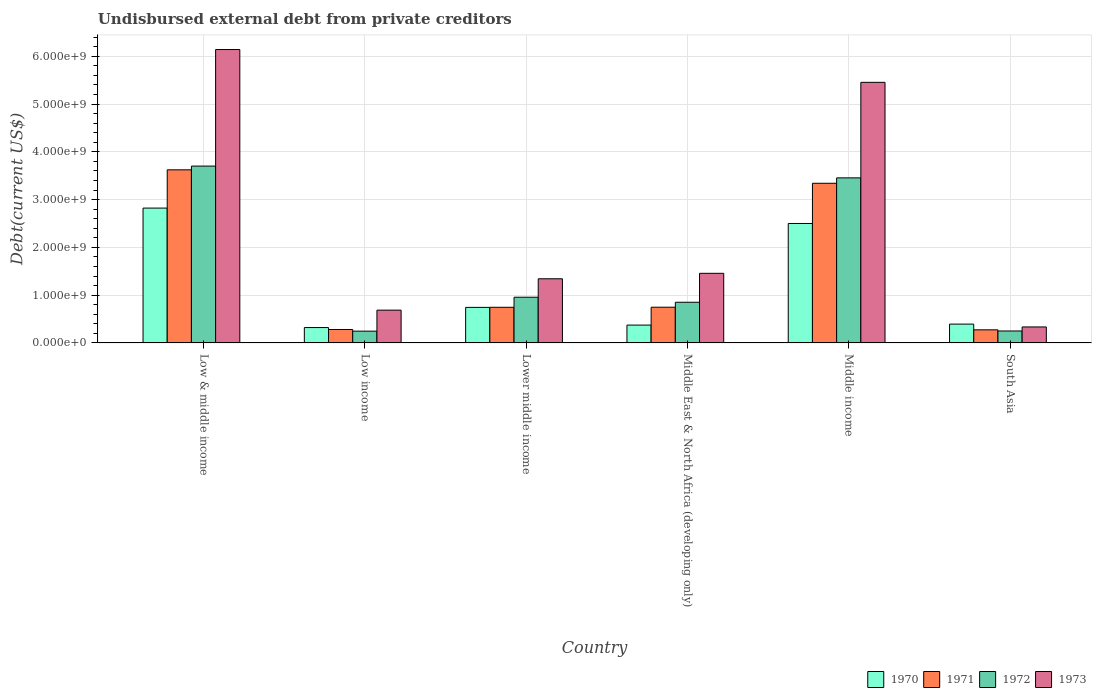How many different coloured bars are there?
Your response must be concise. 4. How many groups of bars are there?
Offer a very short reply. 6. Are the number of bars on each tick of the X-axis equal?
Make the answer very short. Yes. How many bars are there on the 2nd tick from the left?
Offer a very short reply. 4. In how many cases, is the number of bars for a given country not equal to the number of legend labels?
Offer a terse response. 0. What is the total debt in 1972 in Middle East & North Africa (developing only)?
Ensure brevity in your answer.  8.51e+08. Across all countries, what is the maximum total debt in 1971?
Offer a terse response. 3.62e+09. Across all countries, what is the minimum total debt in 1973?
Your response must be concise. 3.35e+08. In which country was the total debt in 1970 minimum?
Offer a very short reply. Low income. What is the total total debt in 1971 in the graph?
Your response must be concise. 9.01e+09. What is the difference between the total debt in 1973 in Low & middle income and that in Middle income?
Offer a terse response. 6.86e+08. What is the difference between the total debt in 1970 in Low income and the total debt in 1973 in Lower middle income?
Provide a succinct answer. -1.02e+09. What is the average total debt in 1971 per country?
Provide a succinct answer. 1.50e+09. What is the difference between the total debt of/in 1970 and total debt of/in 1971 in South Asia?
Offer a terse response. 1.20e+08. In how many countries, is the total debt in 1973 greater than 200000000 US$?
Keep it short and to the point. 6. What is the ratio of the total debt in 1970 in Low income to that in Lower middle income?
Give a very brief answer. 0.43. What is the difference between the highest and the second highest total debt in 1970?
Keep it short and to the point. 2.08e+09. What is the difference between the highest and the lowest total debt in 1973?
Provide a succinct answer. 5.81e+09. Is it the case that in every country, the sum of the total debt in 1973 and total debt in 1972 is greater than the sum of total debt in 1971 and total debt in 1970?
Provide a short and direct response. No. What does the 3rd bar from the left in South Asia represents?
Offer a very short reply. 1972. Are all the bars in the graph horizontal?
Make the answer very short. No. How many countries are there in the graph?
Keep it short and to the point. 6. Are the values on the major ticks of Y-axis written in scientific E-notation?
Your answer should be very brief. Yes. Does the graph contain grids?
Offer a very short reply. Yes. How many legend labels are there?
Ensure brevity in your answer.  4. How are the legend labels stacked?
Offer a terse response. Horizontal. What is the title of the graph?
Keep it short and to the point. Undisbursed external debt from private creditors. What is the label or title of the X-axis?
Make the answer very short. Country. What is the label or title of the Y-axis?
Give a very brief answer. Debt(current US$). What is the Debt(current US$) in 1970 in Low & middle income?
Ensure brevity in your answer.  2.82e+09. What is the Debt(current US$) in 1971 in Low & middle income?
Give a very brief answer. 3.62e+09. What is the Debt(current US$) of 1972 in Low & middle income?
Keep it short and to the point. 3.70e+09. What is the Debt(current US$) in 1973 in Low & middle income?
Provide a succinct answer. 6.14e+09. What is the Debt(current US$) in 1970 in Low income?
Make the answer very short. 3.22e+08. What is the Debt(current US$) of 1971 in Low income?
Ensure brevity in your answer.  2.82e+08. What is the Debt(current US$) in 1972 in Low income?
Your answer should be very brief. 2.47e+08. What is the Debt(current US$) of 1973 in Low income?
Offer a terse response. 6.86e+08. What is the Debt(current US$) of 1970 in Lower middle income?
Ensure brevity in your answer.  7.44e+08. What is the Debt(current US$) in 1971 in Lower middle income?
Your response must be concise. 7.46e+08. What is the Debt(current US$) of 1972 in Lower middle income?
Your answer should be compact. 9.57e+08. What is the Debt(current US$) of 1973 in Lower middle income?
Offer a terse response. 1.34e+09. What is the Debt(current US$) in 1970 in Middle East & North Africa (developing only)?
Provide a short and direct response. 3.74e+08. What is the Debt(current US$) of 1971 in Middle East & North Africa (developing only)?
Offer a very short reply. 7.48e+08. What is the Debt(current US$) in 1972 in Middle East & North Africa (developing only)?
Make the answer very short. 8.51e+08. What is the Debt(current US$) of 1973 in Middle East & North Africa (developing only)?
Make the answer very short. 1.46e+09. What is the Debt(current US$) in 1970 in Middle income?
Make the answer very short. 2.50e+09. What is the Debt(current US$) of 1971 in Middle income?
Make the answer very short. 3.34e+09. What is the Debt(current US$) of 1972 in Middle income?
Your response must be concise. 3.45e+09. What is the Debt(current US$) of 1973 in Middle income?
Provide a short and direct response. 5.45e+09. What is the Debt(current US$) of 1970 in South Asia?
Your answer should be very brief. 3.94e+08. What is the Debt(current US$) of 1971 in South Asia?
Provide a short and direct response. 2.74e+08. What is the Debt(current US$) of 1972 in South Asia?
Your answer should be compact. 2.50e+08. What is the Debt(current US$) in 1973 in South Asia?
Your answer should be very brief. 3.35e+08. Across all countries, what is the maximum Debt(current US$) of 1970?
Offer a terse response. 2.82e+09. Across all countries, what is the maximum Debt(current US$) in 1971?
Offer a terse response. 3.62e+09. Across all countries, what is the maximum Debt(current US$) of 1972?
Your answer should be very brief. 3.70e+09. Across all countries, what is the maximum Debt(current US$) in 1973?
Offer a very short reply. 6.14e+09. Across all countries, what is the minimum Debt(current US$) in 1970?
Keep it short and to the point. 3.22e+08. Across all countries, what is the minimum Debt(current US$) in 1971?
Offer a very short reply. 2.74e+08. Across all countries, what is the minimum Debt(current US$) in 1972?
Your response must be concise. 2.47e+08. Across all countries, what is the minimum Debt(current US$) of 1973?
Your answer should be very brief. 3.35e+08. What is the total Debt(current US$) in 1970 in the graph?
Ensure brevity in your answer.  7.16e+09. What is the total Debt(current US$) of 1971 in the graph?
Your answer should be compact. 9.01e+09. What is the total Debt(current US$) in 1972 in the graph?
Keep it short and to the point. 9.46e+09. What is the total Debt(current US$) of 1973 in the graph?
Ensure brevity in your answer.  1.54e+1. What is the difference between the Debt(current US$) in 1970 in Low & middle income and that in Low income?
Offer a terse response. 2.50e+09. What is the difference between the Debt(current US$) of 1971 in Low & middle income and that in Low income?
Give a very brief answer. 3.34e+09. What is the difference between the Debt(current US$) in 1972 in Low & middle income and that in Low income?
Offer a very short reply. 3.45e+09. What is the difference between the Debt(current US$) in 1973 in Low & middle income and that in Low income?
Offer a terse response. 5.45e+09. What is the difference between the Debt(current US$) in 1970 in Low & middle income and that in Lower middle income?
Provide a succinct answer. 2.08e+09. What is the difference between the Debt(current US$) in 1971 in Low & middle income and that in Lower middle income?
Provide a succinct answer. 2.88e+09. What is the difference between the Debt(current US$) in 1972 in Low & middle income and that in Lower middle income?
Ensure brevity in your answer.  2.74e+09. What is the difference between the Debt(current US$) of 1973 in Low & middle income and that in Lower middle income?
Your response must be concise. 4.80e+09. What is the difference between the Debt(current US$) of 1970 in Low & middle income and that in Middle East & North Africa (developing only)?
Your answer should be very brief. 2.45e+09. What is the difference between the Debt(current US$) in 1971 in Low & middle income and that in Middle East & North Africa (developing only)?
Your response must be concise. 2.88e+09. What is the difference between the Debt(current US$) of 1972 in Low & middle income and that in Middle East & North Africa (developing only)?
Offer a terse response. 2.85e+09. What is the difference between the Debt(current US$) in 1973 in Low & middle income and that in Middle East & North Africa (developing only)?
Your response must be concise. 4.68e+09. What is the difference between the Debt(current US$) in 1970 in Low & middle income and that in Middle income?
Keep it short and to the point. 3.22e+08. What is the difference between the Debt(current US$) of 1971 in Low & middle income and that in Middle income?
Make the answer very short. 2.82e+08. What is the difference between the Debt(current US$) in 1972 in Low & middle income and that in Middle income?
Keep it short and to the point. 2.47e+08. What is the difference between the Debt(current US$) in 1973 in Low & middle income and that in Middle income?
Ensure brevity in your answer.  6.86e+08. What is the difference between the Debt(current US$) of 1970 in Low & middle income and that in South Asia?
Offer a terse response. 2.43e+09. What is the difference between the Debt(current US$) in 1971 in Low & middle income and that in South Asia?
Provide a short and direct response. 3.35e+09. What is the difference between the Debt(current US$) of 1972 in Low & middle income and that in South Asia?
Your response must be concise. 3.45e+09. What is the difference between the Debt(current US$) of 1973 in Low & middle income and that in South Asia?
Offer a terse response. 5.81e+09. What is the difference between the Debt(current US$) of 1970 in Low income and that in Lower middle income?
Keep it short and to the point. -4.22e+08. What is the difference between the Debt(current US$) in 1971 in Low income and that in Lower middle income?
Give a very brief answer. -4.65e+08. What is the difference between the Debt(current US$) of 1972 in Low income and that in Lower middle income?
Give a very brief answer. -7.10e+08. What is the difference between the Debt(current US$) in 1973 in Low income and that in Lower middle income?
Your answer should be very brief. -6.56e+08. What is the difference between the Debt(current US$) of 1970 in Low income and that in Middle East & North Africa (developing only)?
Make the answer very short. -5.15e+07. What is the difference between the Debt(current US$) of 1971 in Low income and that in Middle East & North Africa (developing only)?
Give a very brief answer. -4.66e+08. What is the difference between the Debt(current US$) in 1972 in Low income and that in Middle East & North Africa (developing only)?
Ensure brevity in your answer.  -6.05e+08. What is the difference between the Debt(current US$) in 1973 in Low income and that in Middle East & North Africa (developing only)?
Your answer should be compact. -7.71e+08. What is the difference between the Debt(current US$) of 1970 in Low income and that in Middle income?
Provide a short and direct response. -2.18e+09. What is the difference between the Debt(current US$) of 1971 in Low income and that in Middle income?
Offer a very short reply. -3.06e+09. What is the difference between the Debt(current US$) of 1972 in Low income and that in Middle income?
Ensure brevity in your answer.  -3.21e+09. What is the difference between the Debt(current US$) of 1973 in Low income and that in Middle income?
Offer a very short reply. -4.77e+09. What is the difference between the Debt(current US$) of 1970 in Low income and that in South Asia?
Offer a terse response. -7.22e+07. What is the difference between the Debt(current US$) of 1971 in Low income and that in South Asia?
Your answer should be compact. 7.14e+06. What is the difference between the Debt(current US$) in 1972 in Low income and that in South Asia?
Keep it short and to the point. -3.44e+06. What is the difference between the Debt(current US$) in 1973 in Low income and that in South Asia?
Your response must be concise. 3.52e+08. What is the difference between the Debt(current US$) of 1970 in Lower middle income and that in Middle East & North Africa (developing only)?
Ensure brevity in your answer.  3.71e+08. What is the difference between the Debt(current US$) of 1971 in Lower middle income and that in Middle East & North Africa (developing only)?
Your answer should be compact. -1.62e+06. What is the difference between the Debt(current US$) of 1972 in Lower middle income and that in Middle East & North Africa (developing only)?
Keep it short and to the point. 1.05e+08. What is the difference between the Debt(current US$) of 1973 in Lower middle income and that in Middle East & North Africa (developing only)?
Provide a succinct answer. -1.14e+08. What is the difference between the Debt(current US$) of 1970 in Lower middle income and that in Middle income?
Ensure brevity in your answer.  -1.76e+09. What is the difference between the Debt(current US$) in 1971 in Lower middle income and that in Middle income?
Provide a short and direct response. -2.60e+09. What is the difference between the Debt(current US$) of 1972 in Lower middle income and that in Middle income?
Your answer should be compact. -2.50e+09. What is the difference between the Debt(current US$) of 1973 in Lower middle income and that in Middle income?
Make the answer very short. -4.11e+09. What is the difference between the Debt(current US$) in 1970 in Lower middle income and that in South Asia?
Make the answer very short. 3.50e+08. What is the difference between the Debt(current US$) of 1971 in Lower middle income and that in South Asia?
Provide a short and direct response. 4.72e+08. What is the difference between the Debt(current US$) of 1972 in Lower middle income and that in South Asia?
Your answer should be very brief. 7.07e+08. What is the difference between the Debt(current US$) in 1973 in Lower middle income and that in South Asia?
Provide a short and direct response. 1.01e+09. What is the difference between the Debt(current US$) in 1970 in Middle East & North Africa (developing only) and that in Middle income?
Give a very brief answer. -2.13e+09. What is the difference between the Debt(current US$) in 1971 in Middle East & North Africa (developing only) and that in Middle income?
Your answer should be compact. -2.59e+09. What is the difference between the Debt(current US$) of 1972 in Middle East & North Africa (developing only) and that in Middle income?
Keep it short and to the point. -2.60e+09. What is the difference between the Debt(current US$) of 1973 in Middle East & North Africa (developing only) and that in Middle income?
Provide a short and direct response. -4.00e+09. What is the difference between the Debt(current US$) in 1970 in Middle East & North Africa (developing only) and that in South Asia?
Offer a very short reply. -2.07e+07. What is the difference between the Debt(current US$) in 1971 in Middle East & North Africa (developing only) and that in South Asia?
Provide a short and direct response. 4.74e+08. What is the difference between the Debt(current US$) of 1972 in Middle East & North Africa (developing only) and that in South Asia?
Offer a terse response. 6.01e+08. What is the difference between the Debt(current US$) in 1973 in Middle East & North Africa (developing only) and that in South Asia?
Your answer should be very brief. 1.12e+09. What is the difference between the Debt(current US$) of 1970 in Middle income and that in South Asia?
Give a very brief answer. 2.11e+09. What is the difference between the Debt(current US$) in 1971 in Middle income and that in South Asia?
Provide a short and direct response. 3.07e+09. What is the difference between the Debt(current US$) in 1972 in Middle income and that in South Asia?
Keep it short and to the point. 3.20e+09. What is the difference between the Debt(current US$) of 1973 in Middle income and that in South Asia?
Your response must be concise. 5.12e+09. What is the difference between the Debt(current US$) in 1970 in Low & middle income and the Debt(current US$) in 1971 in Low income?
Provide a succinct answer. 2.54e+09. What is the difference between the Debt(current US$) in 1970 in Low & middle income and the Debt(current US$) in 1972 in Low income?
Make the answer very short. 2.58e+09. What is the difference between the Debt(current US$) of 1970 in Low & middle income and the Debt(current US$) of 1973 in Low income?
Give a very brief answer. 2.14e+09. What is the difference between the Debt(current US$) of 1971 in Low & middle income and the Debt(current US$) of 1972 in Low income?
Your answer should be compact. 3.38e+09. What is the difference between the Debt(current US$) in 1971 in Low & middle income and the Debt(current US$) in 1973 in Low income?
Your answer should be very brief. 2.94e+09. What is the difference between the Debt(current US$) of 1972 in Low & middle income and the Debt(current US$) of 1973 in Low income?
Make the answer very short. 3.02e+09. What is the difference between the Debt(current US$) of 1970 in Low & middle income and the Debt(current US$) of 1971 in Lower middle income?
Offer a very short reply. 2.08e+09. What is the difference between the Debt(current US$) in 1970 in Low & middle income and the Debt(current US$) in 1972 in Lower middle income?
Make the answer very short. 1.87e+09. What is the difference between the Debt(current US$) in 1970 in Low & middle income and the Debt(current US$) in 1973 in Lower middle income?
Provide a short and direct response. 1.48e+09. What is the difference between the Debt(current US$) of 1971 in Low & middle income and the Debt(current US$) of 1972 in Lower middle income?
Keep it short and to the point. 2.67e+09. What is the difference between the Debt(current US$) in 1971 in Low & middle income and the Debt(current US$) in 1973 in Lower middle income?
Provide a short and direct response. 2.28e+09. What is the difference between the Debt(current US$) in 1972 in Low & middle income and the Debt(current US$) in 1973 in Lower middle income?
Offer a terse response. 2.36e+09. What is the difference between the Debt(current US$) of 1970 in Low & middle income and the Debt(current US$) of 1971 in Middle East & North Africa (developing only)?
Provide a succinct answer. 2.07e+09. What is the difference between the Debt(current US$) of 1970 in Low & middle income and the Debt(current US$) of 1972 in Middle East & North Africa (developing only)?
Offer a very short reply. 1.97e+09. What is the difference between the Debt(current US$) in 1970 in Low & middle income and the Debt(current US$) in 1973 in Middle East & North Africa (developing only)?
Keep it short and to the point. 1.37e+09. What is the difference between the Debt(current US$) in 1971 in Low & middle income and the Debt(current US$) in 1972 in Middle East & North Africa (developing only)?
Your answer should be very brief. 2.77e+09. What is the difference between the Debt(current US$) in 1971 in Low & middle income and the Debt(current US$) in 1973 in Middle East & North Africa (developing only)?
Give a very brief answer. 2.17e+09. What is the difference between the Debt(current US$) in 1972 in Low & middle income and the Debt(current US$) in 1973 in Middle East & North Africa (developing only)?
Give a very brief answer. 2.24e+09. What is the difference between the Debt(current US$) in 1970 in Low & middle income and the Debt(current US$) in 1971 in Middle income?
Your answer should be very brief. -5.19e+08. What is the difference between the Debt(current US$) in 1970 in Low & middle income and the Debt(current US$) in 1972 in Middle income?
Your answer should be very brief. -6.32e+08. What is the difference between the Debt(current US$) of 1970 in Low & middle income and the Debt(current US$) of 1973 in Middle income?
Make the answer very short. -2.63e+09. What is the difference between the Debt(current US$) in 1971 in Low & middle income and the Debt(current US$) in 1972 in Middle income?
Your answer should be very brief. 1.68e+08. What is the difference between the Debt(current US$) of 1971 in Low & middle income and the Debt(current US$) of 1973 in Middle income?
Offer a very short reply. -1.83e+09. What is the difference between the Debt(current US$) in 1972 in Low & middle income and the Debt(current US$) in 1973 in Middle income?
Make the answer very short. -1.75e+09. What is the difference between the Debt(current US$) of 1970 in Low & middle income and the Debt(current US$) of 1971 in South Asia?
Offer a very short reply. 2.55e+09. What is the difference between the Debt(current US$) in 1970 in Low & middle income and the Debt(current US$) in 1972 in South Asia?
Provide a succinct answer. 2.57e+09. What is the difference between the Debt(current US$) of 1970 in Low & middle income and the Debt(current US$) of 1973 in South Asia?
Provide a short and direct response. 2.49e+09. What is the difference between the Debt(current US$) in 1971 in Low & middle income and the Debt(current US$) in 1972 in South Asia?
Your response must be concise. 3.37e+09. What is the difference between the Debt(current US$) in 1971 in Low & middle income and the Debt(current US$) in 1973 in South Asia?
Provide a short and direct response. 3.29e+09. What is the difference between the Debt(current US$) in 1972 in Low & middle income and the Debt(current US$) in 1973 in South Asia?
Offer a very short reply. 3.37e+09. What is the difference between the Debt(current US$) of 1970 in Low income and the Debt(current US$) of 1971 in Lower middle income?
Provide a short and direct response. -4.24e+08. What is the difference between the Debt(current US$) in 1970 in Low income and the Debt(current US$) in 1972 in Lower middle income?
Make the answer very short. -6.35e+08. What is the difference between the Debt(current US$) of 1970 in Low income and the Debt(current US$) of 1973 in Lower middle income?
Make the answer very short. -1.02e+09. What is the difference between the Debt(current US$) in 1971 in Low income and the Debt(current US$) in 1972 in Lower middle income?
Provide a short and direct response. -6.75e+08. What is the difference between the Debt(current US$) in 1971 in Low income and the Debt(current US$) in 1973 in Lower middle income?
Provide a succinct answer. -1.06e+09. What is the difference between the Debt(current US$) in 1972 in Low income and the Debt(current US$) in 1973 in Lower middle income?
Keep it short and to the point. -1.10e+09. What is the difference between the Debt(current US$) in 1970 in Low income and the Debt(current US$) in 1971 in Middle East & North Africa (developing only)?
Your answer should be very brief. -4.26e+08. What is the difference between the Debt(current US$) of 1970 in Low income and the Debt(current US$) of 1972 in Middle East & North Africa (developing only)?
Keep it short and to the point. -5.29e+08. What is the difference between the Debt(current US$) in 1970 in Low income and the Debt(current US$) in 1973 in Middle East & North Africa (developing only)?
Your answer should be compact. -1.13e+09. What is the difference between the Debt(current US$) of 1971 in Low income and the Debt(current US$) of 1972 in Middle East & North Africa (developing only)?
Ensure brevity in your answer.  -5.70e+08. What is the difference between the Debt(current US$) in 1971 in Low income and the Debt(current US$) in 1973 in Middle East & North Africa (developing only)?
Your response must be concise. -1.18e+09. What is the difference between the Debt(current US$) of 1972 in Low income and the Debt(current US$) of 1973 in Middle East & North Africa (developing only)?
Offer a very short reply. -1.21e+09. What is the difference between the Debt(current US$) of 1970 in Low income and the Debt(current US$) of 1971 in Middle income?
Ensure brevity in your answer.  -3.02e+09. What is the difference between the Debt(current US$) of 1970 in Low income and the Debt(current US$) of 1972 in Middle income?
Your answer should be compact. -3.13e+09. What is the difference between the Debt(current US$) of 1970 in Low income and the Debt(current US$) of 1973 in Middle income?
Make the answer very short. -5.13e+09. What is the difference between the Debt(current US$) in 1971 in Low income and the Debt(current US$) in 1972 in Middle income?
Give a very brief answer. -3.17e+09. What is the difference between the Debt(current US$) of 1971 in Low income and the Debt(current US$) of 1973 in Middle income?
Your answer should be very brief. -5.17e+09. What is the difference between the Debt(current US$) of 1972 in Low income and the Debt(current US$) of 1973 in Middle income?
Your answer should be very brief. -5.21e+09. What is the difference between the Debt(current US$) of 1970 in Low income and the Debt(current US$) of 1971 in South Asia?
Provide a succinct answer. 4.77e+07. What is the difference between the Debt(current US$) of 1970 in Low income and the Debt(current US$) of 1972 in South Asia?
Your answer should be very brief. 7.18e+07. What is the difference between the Debt(current US$) in 1970 in Low income and the Debt(current US$) in 1973 in South Asia?
Your answer should be compact. -1.27e+07. What is the difference between the Debt(current US$) in 1971 in Low income and the Debt(current US$) in 1972 in South Asia?
Your response must be concise. 3.13e+07. What is the difference between the Debt(current US$) of 1971 in Low income and the Debt(current US$) of 1973 in South Asia?
Make the answer very short. -5.33e+07. What is the difference between the Debt(current US$) in 1972 in Low income and the Debt(current US$) in 1973 in South Asia?
Ensure brevity in your answer.  -8.80e+07. What is the difference between the Debt(current US$) in 1970 in Lower middle income and the Debt(current US$) in 1971 in Middle East & North Africa (developing only)?
Ensure brevity in your answer.  -3.71e+06. What is the difference between the Debt(current US$) of 1970 in Lower middle income and the Debt(current US$) of 1972 in Middle East & North Africa (developing only)?
Provide a succinct answer. -1.07e+08. What is the difference between the Debt(current US$) in 1970 in Lower middle income and the Debt(current US$) in 1973 in Middle East & North Africa (developing only)?
Your response must be concise. -7.13e+08. What is the difference between the Debt(current US$) of 1971 in Lower middle income and the Debt(current US$) of 1972 in Middle East & North Africa (developing only)?
Ensure brevity in your answer.  -1.05e+08. What is the difference between the Debt(current US$) of 1971 in Lower middle income and the Debt(current US$) of 1973 in Middle East & North Africa (developing only)?
Your answer should be very brief. -7.11e+08. What is the difference between the Debt(current US$) of 1972 in Lower middle income and the Debt(current US$) of 1973 in Middle East & North Africa (developing only)?
Make the answer very short. -5.00e+08. What is the difference between the Debt(current US$) in 1970 in Lower middle income and the Debt(current US$) in 1971 in Middle income?
Your response must be concise. -2.60e+09. What is the difference between the Debt(current US$) of 1970 in Lower middle income and the Debt(current US$) of 1972 in Middle income?
Your response must be concise. -2.71e+09. What is the difference between the Debt(current US$) in 1970 in Lower middle income and the Debt(current US$) in 1973 in Middle income?
Offer a very short reply. -4.71e+09. What is the difference between the Debt(current US$) of 1971 in Lower middle income and the Debt(current US$) of 1972 in Middle income?
Provide a short and direct response. -2.71e+09. What is the difference between the Debt(current US$) in 1971 in Lower middle income and the Debt(current US$) in 1973 in Middle income?
Your answer should be compact. -4.71e+09. What is the difference between the Debt(current US$) in 1972 in Lower middle income and the Debt(current US$) in 1973 in Middle income?
Your response must be concise. -4.50e+09. What is the difference between the Debt(current US$) of 1970 in Lower middle income and the Debt(current US$) of 1971 in South Asia?
Your answer should be compact. 4.70e+08. What is the difference between the Debt(current US$) in 1970 in Lower middle income and the Debt(current US$) in 1972 in South Asia?
Ensure brevity in your answer.  4.94e+08. What is the difference between the Debt(current US$) in 1970 in Lower middle income and the Debt(current US$) in 1973 in South Asia?
Your response must be concise. 4.09e+08. What is the difference between the Debt(current US$) of 1971 in Lower middle income and the Debt(current US$) of 1972 in South Asia?
Your answer should be compact. 4.96e+08. What is the difference between the Debt(current US$) in 1971 in Lower middle income and the Debt(current US$) in 1973 in South Asia?
Provide a short and direct response. 4.11e+08. What is the difference between the Debt(current US$) in 1972 in Lower middle income and the Debt(current US$) in 1973 in South Asia?
Your response must be concise. 6.22e+08. What is the difference between the Debt(current US$) in 1970 in Middle East & North Africa (developing only) and the Debt(current US$) in 1971 in Middle income?
Give a very brief answer. -2.97e+09. What is the difference between the Debt(current US$) in 1970 in Middle East & North Africa (developing only) and the Debt(current US$) in 1972 in Middle income?
Your answer should be very brief. -3.08e+09. What is the difference between the Debt(current US$) in 1970 in Middle East & North Africa (developing only) and the Debt(current US$) in 1973 in Middle income?
Offer a terse response. -5.08e+09. What is the difference between the Debt(current US$) of 1971 in Middle East & North Africa (developing only) and the Debt(current US$) of 1972 in Middle income?
Offer a very short reply. -2.71e+09. What is the difference between the Debt(current US$) in 1971 in Middle East & North Africa (developing only) and the Debt(current US$) in 1973 in Middle income?
Offer a very short reply. -4.71e+09. What is the difference between the Debt(current US$) in 1972 in Middle East & North Africa (developing only) and the Debt(current US$) in 1973 in Middle income?
Make the answer very short. -4.60e+09. What is the difference between the Debt(current US$) of 1970 in Middle East & North Africa (developing only) and the Debt(current US$) of 1971 in South Asia?
Give a very brief answer. 9.92e+07. What is the difference between the Debt(current US$) of 1970 in Middle East & North Africa (developing only) and the Debt(current US$) of 1972 in South Asia?
Your answer should be compact. 1.23e+08. What is the difference between the Debt(current US$) in 1970 in Middle East & North Africa (developing only) and the Debt(current US$) in 1973 in South Asia?
Your response must be concise. 3.88e+07. What is the difference between the Debt(current US$) of 1971 in Middle East & North Africa (developing only) and the Debt(current US$) of 1972 in South Asia?
Provide a short and direct response. 4.98e+08. What is the difference between the Debt(current US$) of 1971 in Middle East & North Africa (developing only) and the Debt(current US$) of 1973 in South Asia?
Your answer should be compact. 4.13e+08. What is the difference between the Debt(current US$) in 1972 in Middle East & North Africa (developing only) and the Debt(current US$) in 1973 in South Asia?
Make the answer very short. 5.17e+08. What is the difference between the Debt(current US$) in 1970 in Middle income and the Debt(current US$) in 1971 in South Asia?
Keep it short and to the point. 2.23e+09. What is the difference between the Debt(current US$) of 1970 in Middle income and the Debt(current US$) of 1972 in South Asia?
Give a very brief answer. 2.25e+09. What is the difference between the Debt(current US$) of 1970 in Middle income and the Debt(current US$) of 1973 in South Asia?
Your answer should be very brief. 2.17e+09. What is the difference between the Debt(current US$) of 1971 in Middle income and the Debt(current US$) of 1972 in South Asia?
Provide a succinct answer. 3.09e+09. What is the difference between the Debt(current US$) in 1971 in Middle income and the Debt(current US$) in 1973 in South Asia?
Ensure brevity in your answer.  3.01e+09. What is the difference between the Debt(current US$) in 1972 in Middle income and the Debt(current US$) in 1973 in South Asia?
Your answer should be very brief. 3.12e+09. What is the average Debt(current US$) of 1970 per country?
Give a very brief answer. 1.19e+09. What is the average Debt(current US$) in 1971 per country?
Make the answer very short. 1.50e+09. What is the average Debt(current US$) of 1972 per country?
Your answer should be very brief. 1.58e+09. What is the average Debt(current US$) in 1973 per country?
Offer a terse response. 2.57e+09. What is the difference between the Debt(current US$) in 1970 and Debt(current US$) in 1971 in Low & middle income?
Offer a very short reply. -8.01e+08. What is the difference between the Debt(current US$) of 1970 and Debt(current US$) of 1972 in Low & middle income?
Make the answer very short. -8.79e+08. What is the difference between the Debt(current US$) of 1970 and Debt(current US$) of 1973 in Low & middle income?
Make the answer very short. -3.32e+09. What is the difference between the Debt(current US$) in 1971 and Debt(current US$) in 1972 in Low & middle income?
Provide a short and direct response. -7.84e+07. What is the difference between the Debt(current US$) of 1971 and Debt(current US$) of 1973 in Low & middle income?
Give a very brief answer. -2.52e+09. What is the difference between the Debt(current US$) of 1972 and Debt(current US$) of 1973 in Low & middle income?
Give a very brief answer. -2.44e+09. What is the difference between the Debt(current US$) of 1970 and Debt(current US$) of 1971 in Low income?
Ensure brevity in your answer.  4.06e+07. What is the difference between the Debt(current US$) in 1970 and Debt(current US$) in 1972 in Low income?
Ensure brevity in your answer.  7.53e+07. What is the difference between the Debt(current US$) in 1970 and Debt(current US$) in 1973 in Low income?
Offer a terse response. -3.64e+08. What is the difference between the Debt(current US$) of 1971 and Debt(current US$) of 1972 in Low income?
Give a very brief answer. 3.47e+07. What is the difference between the Debt(current US$) in 1971 and Debt(current US$) in 1973 in Low income?
Your answer should be very brief. -4.05e+08. What is the difference between the Debt(current US$) in 1972 and Debt(current US$) in 1973 in Low income?
Offer a terse response. -4.40e+08. What is the difference between the Debt(current US$) in 1970 and Debt(current US$) in 1971 in Lower middle income?
Provide a succinct answer. -2.10e+06. What is the difference between the Debt(current US$) of 1970 and Debt(current US$) of 1972 in Lower middle income?
Provide a short and direct response. -2.13e+08. What is the difference between the Debt(current US$) in 1970 and Debt(current US$) in 1973 in Lower middle income?
Offer a very short reply. -5.99e+08. What is the difference between the Debt(current US$) in 1971 and Debt(current US$) in 1972 in Lower middle income?
Make the answer very short. -2.11e+08. What is the difference between the Debt(current US$) of 1971 and Debt(current US$) of 1973 in Lower middle income?
Give a very brief answer. -5.97e+08. What is the difference between the Debt(current US$) of 1972 and Debt(current US$) of 1973 in Lower middle income?
Your answer should be compact. -3.86e+08. What is the difference between the Debt(current US$) of 1970 and Debt(current US$) of 1971 in Middle East & North Africa (developing only)?
Your answer should be compact. -3.74e+08. What is the difference between the Debt(current US$) of 1970 and Debt(current US$) of 1972 in Middle East & North Africa (developing only)?
Your answer should be very brief. -4.78e+08. What is the difference between the Debt(current US$) of 1970 and Debt(current US$) of 1973 in Middle East & North Africa (developing only)?
Your answer should be very brief. -1.08e+09. What is the difference between the Debt(current US$) of 1971 and Debt(current US$) of 1972 in Middle East & North Africa (developing only)?
Provide a short and direct response. -1.04e+08. What is the difference between the Debt(current US$) of 1971 and Debt(current US$) of 1973 in Middle East & North Africa (developing only)?
Make the answer very short. -7.09e+08. What is the difference between the Debt(current US$) in 1972 and Debt(current US$) in 1973 in Middle East & North Africa (developing only)?
Provide a short and direct response. -6.06e+08. What is the difference between the Debt(current US$) of 1970 and Debt(current US$) of 1971 in Middle income?
Provide a succinct answer. -8.41e+08. What is the difference between the Debt(current US$) of 1970 and Debt(current US$) of 1972 in Middle income?
Your answer should be compact. -9.54e+08. What is the difference between the Debt(current US$) of 1970 and Debt(current US$) of 1973 in Middle income?
Your response must be concise. -2.95e+09. What is the difference between the Debt(current US$) of 1971 and Debt(current US$) of 1972 in Middle income?
Give a very brief answer. -1.13e+08. What is the difference between the Debt(current US$) in 1971 and Debt(current US$) in 1973 in Middle income?
Your response must be concise. -2.11e+09. What is the difference between the Debt(current US$) of 1972 and Debt(current US$) of 1973 in Middle income?
Offer a terse response. -2.00e+09. What is the difference between the Debt(current US$) of 1970 and Debt(current US$) of 1971 in South Asia?
Provide a succinct answer. 1.20e+08. What is the difference between the Debt(current US$) of 1970 and Debt(current US$) of 1972 in South Asia?
Your answer should be compact. 1.44e+08. What is the difference between the Debt(current US$) of 1970 and Debt(current US$) of 1973 in South Asia?
Give a very brief answer. 5.95e+07. What is the difference between the Debt(current US$) of 1971 and Debt(current US$) of 1972 in South Asia?
Offer a very short reply. 2.41e+07. What is the difference between the Debt(current US$) in 1971 and Debt(current US$) in 1973 in South Asia?
Provide a short and direct response. -6.04e+07. What is the difference between the Debt(current US$) in 1972 and Debt(current US$) in 1973 in South Asia?
Ensure brevity in your answer.  -8.45e+07. What is the ratio of the Debt(current US$) of 1970 in Low & middle income to that in Low income?
Ensure brevity in your answer.  8.76. What is the ratio of the Debt(current US$) of 1971 in Low & middle income to that in Low income?
Give a very brief answer. 12.87. What is the ratio of the Debt(current US$) of 1972 in Low & middle income to that in Low income?
Your response must be concise. 15. What is the ratio of the Debt(current US$) of 1973 in Low & middle income to that in Low income?
Give a very brief answer. 8.95. What is the ratio of the Debt(current US$) in 1970 in Low & middle income to that in Lower middle income?
Offer a terse response. 3.79. What is the ratio of the Debt(current US$) of 1971 in Low & middle income to that in Lower middle income?
Keep it short and to the point. 4.86. What is the ratio of the Debt(current US$) of 1972 in Low & middle income to that in Lower middle income?
Provide a succinct answer. 3.87. What is the ratio of the Debt(current US$) in 1973 in Low & middle income to that in Lower middle income?
Your response must be concise. 4.57. What is the ratio of the Debt(current US$) in 1970 in Low & middle income to that in Middle East & North Africa (developing only)?
Offer a terse response. 7.55. What is the ratio of the Debt(current US$) in 1971 in Low & middle income to that in Middle East & North Africa (developing only)?
Offer a very short reply. 4.84. What is the ratio of the Debt(current US$) of 1972 in Low & middle income to that in Middle East & North Africa (developing only)?
Offer a terse response. 4.35. What is the ratio of the Debt(current US$) of 1973 in Low & middle income to that in Middle East & North Africa (developing only)?
Keep it short and to the point. 4.21. What is the ratio of the Debt(current US$) of 1970 in Low & middle income to that in Middle income?
Give a very brief answer. 1.13. What is the ratio of the Debt(current US$) in 1971 in Low & middle income to that in Middle income?
Give a very brief answer. 1.08. What is the ratio of the Debt(current US$) of 1972 in Low & middle income to that in Middle income?
Your answer should be compact. 1.07. What is the ratio of the Debt(current US$) in 1973 in Low & middle income to that in Middle income?
Offer a very short reply. 1.13. What is the ratio of the Debt(current US$) in 1970 in Low & middle income to that in South Asia?
Your answer should be very brief. 7.16. What is the ratio of the Debt(current US$) of 1971 in Low & middle income to that in South Asia?
Give a very brief answer. 13.2. What is the ratio of the Debt(current US$) in 1972 in Low & middle income to that in South Asia?
Give a very brief answer. 14.79. What is the ratio of the Debt(current US$) in 1973 in Low & middle income to that in South Asia?
Your answer should be compact. 18.34. What is the ratio of the Debt(current US$) in 1970 in Low income to that in Lower middle income?
Provide a short and direct response. 0.43. What is the ratio of the Debt(current US$) in 1971 in Low income to that in Lower middle income?
Give a very brief answer. 0.38. What is the ratio of the Debt(current US$) of 1972 in Low income to that in Lower middle income?
Offer a terse response. 0.26. What is the ratio of the Debt(current US$) of 1973 in Low income to that in Lower middle income?
Your answer should be very brief. 0.51. What is the ratio of the Debt(current US$) in 1970 in Low income to that in Middle East & North Africa (developing only)?
Keep it short and to the point. 0.86. What is the ratio of the Debt(current US$) of 1971 in Low income to that in Middle East & North Africa (developing only)?
Offer a very short reply. 0.38. What is the ratio of the Debt(current US$) of 1972 in Low income to that in Middle East & North Africa (developing only)?
Provide a succinct answer. 0.29. What is the ratio of the Debt(current US$) in 1973 in Low income to that in Middle East & North Africa (developing only)?
Your answer should be very brief. 0.47. What is the ratio of the Debt(current US$) in 1970 in Low income to that in Middle income?
Make the answer very short. 0.13. What is the ratio of the Debt(current US$) of 1971 in Low income to that in Middle income?
Offer a terse response. 0.08. What is the ratio of the Debt(current US$) in 1972 in Low income to that in Middle income?
Your answer should be very brief. 0.07. What is the ratio of the Debt(current US$) in 1973 in Low income to that in Middle income?
Make the answer very short. 0.13. What is the ratio of the Debt(current US$) in 1970 in Low income to that in South Asia?
Your answer should be compact. 0.82. What is the ratio of the Debt(current US$) in 1972 in Low income to that in South Asia?
Keep it short and to the point. 0.99. What is the ratio of the Debt(current US$) in 1973 in Low income to that in South Asia?
Offer a terse response. 2.05. What is the ratio of the Debt(current US$) of 1970 in Lower middle income to that in Middle East & North Africa (developing only)?
Your answer should be compact. 1.99. What is the ratio of the Debt(current US$) in 1971 in Lower middle income to that in Middle East & North Africa (developing only)?
Provide a succinct answer. 1. What is the ratio of the Debt(current US$) in 1972 in Lower middle income to that in Middle East & North Africa (developing only)?
Your answer should be very brief. 1.12. What is the ratio of the Debt(current US$) in 1973 in Lower middle income to that in Middle East & North Africa (developing only)?
Offer a terse response. 0.92. What is the ratio of the Debt(current US$) in 1970 in Lower middle income to that in Middle income?
Offer a very short reply. 0.3. What is the ratio of the Debt(current US$) of 1971 in Lower middle income to that in Middle income?
Your answer should be very brief. 0.22. What is the ratio of the Debt(current US$) in 1972 in Lower middle income to that in Middle income?
Your answer should be very brief. 0.28. What is the ratio of the Debt(current US$) in 1973 in Lower middle income to that in Middle income?
Your answer should be very brief. 0.25. What is the ratio of the Debt(current US$) of 1970 in Lower middle income to that in South Asia?
Make the answer very short. 1.89. What is the ratio of the Debt(current US$) in 1971 in Lower middle income to that in South Asia?
Provide a short and direct response. 2.72. What is the ratio of the Debt(current US$) in 1972 in Lower middle income to that in South Asia?
Provide a short and direct response. 3.82. What is the ratio of the Debt(current US$) of 1973 in Lower middle income to that in South Asia?
Keep it short and to the point. 4.01. What is the ratio of the Debt(current US$) of 1970 in Middle East & North Africa (developing only) to that in Middle income?
Make the answer very short. 0.15. What is the ratio of the Debt(current US$) of 1971 in Middle East & North Africa (developing only) to that in Middle income?
Ensure brevity in your answer.  0.22. What is the ratio of the Debt(current US$) in 1972 in Middle East & North Africa (developing only) to that in Middle income?
Provide a succinct answer. 0.25. What is the ratio of the Debt(current US$) in 1973 in Middle East & North Africa (developing only) to that in Middle income?
Offer a terse response. 0.27. What is the ratio of the Debt(current US$) of 1970 in Middle East & North Africa (developing only) to that in South Asia?
Offer a very short reply. 0.95. What is the ratio of the Debt(current US$) of 1971 in Middle East & North Africa (developing only) to that in South Asia?
Provide a succinct answer. 2.73. What is the ratio of the Debt(current US$) of 1972 in Middle East & North Africa (developing only) to that in South Asia?
Offer a very short reply. 3.4. What is the ratio of the Debt(current US$) of 1973 in Middle East & North Africa (developing only) to that in South Asia?
Give a very brief answer. 4.35. What is the ratio of the Debt(current US$) in 1970 in Middle income to that in South Asia?
Keep it short and to the point. 6.34. What is the ratio of the Debt(current US$) in 1971 in Middle income to that in South Asia?
Keep it short and to the point. 12.18. What is the ratio of the Debt(current US$) in 1972 in Middle income to that in South Asia?
Your answer should be compact. 13.8. What is the ratio of the Debt(current US$) of 1973 in Middle income to that in South Asia?
Your response must be concise. 16.29. What is the difference between the highest and the second highest Debt(current US$) in 1970?
Your answer should be compact. 3.22e+08. What is the difference between the highest and the second highest Debt(current US$) in 1971?
Provide a succinct answer. 2.82e+08. What is the difference between the highest and the second highest Debt(current US$) in 1972?
Make the answer very short. 2.47e+08. What is the difference between the highest and the second highest Debt(current US$) in 1973?
Provide a succinct answer. 6.86e+08. What is the difference between the highest and the lowest Debt(current US$) in 1970?
Offer a terse response. 2.50e+09. What is the difference between the highest and the lowest Debt(current US$) of 1971?
Offer a terse response. 3.35e+09. What is the difference between the highest and the lowest Debt(current US$) in 1972?
Ensure brevity in your answer.  3.45e+09. What is the difference between the highest and the lowest Debt(current US$) in 1973?
Keep it short and to the point. 5.81e+09. 